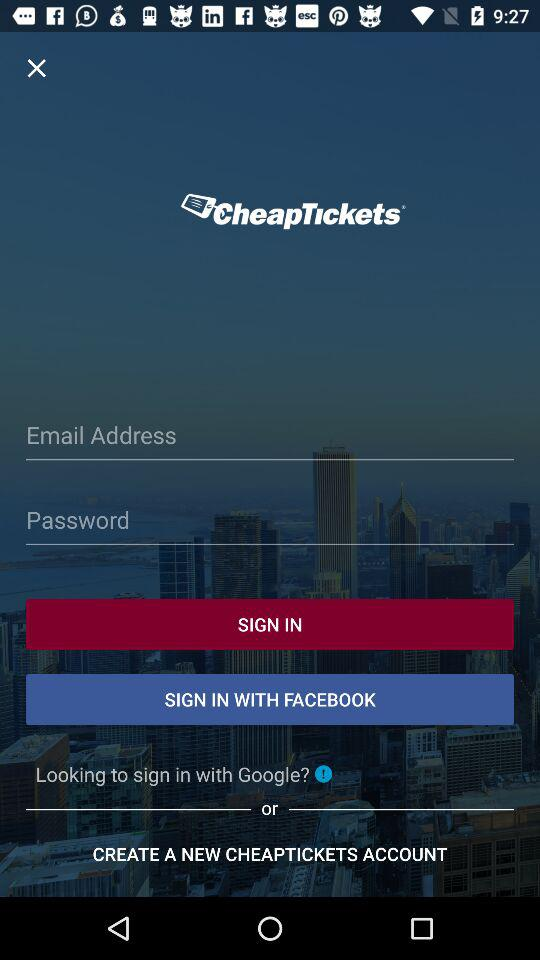What accounts can I use to sign up? You can use "Email", "FACEBOOK" and "Google" accounts. 